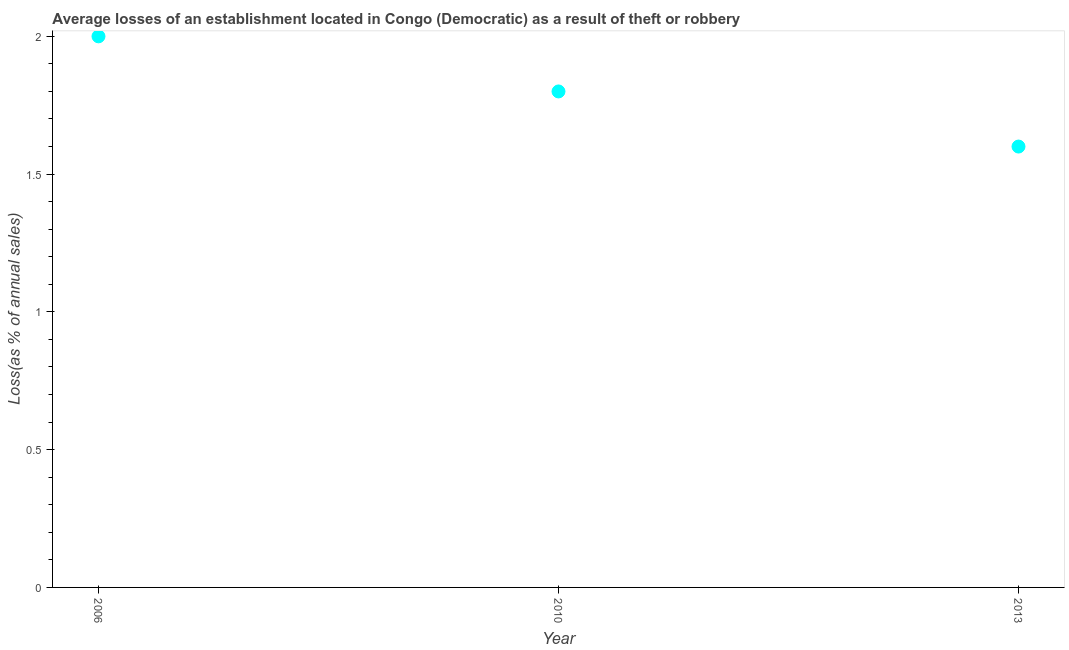What is the losses due to theft in 2013?
Offer a very short reply. 1.6. In which year was the losses due to theft maximum?
Keep it short and to the point. 2006. In which year was the losses due to theft minimum?
Offer a very short reply. 2013. What is the difference between the losses due to theft in 2006 and 2010?
Provide a short and direct response. 0.2. What is the average losses due to theft per year?
Your answer should be very brief. 1.8. What is the median losses due to theft?
Make the answer very short. 1.8. In how many years, is the losses due to theft greater than 0.2 %?
Your answer should be compact. 3. Do a majority of the years between 2006 and 2013 (inclusive) have losses due to theft greater than 1.3 %?
Your response must be concise. Yes. Is the losses due to theft in 2006 less than that in 2010?
Keep it short and to the point. No. What is the difference between the highest and the second highest losses due to theft?
Your response must be concise. 0.2. What is the difference between the highest and the lowest losses due to theft?
Offer a very short reply. 0.4. How many dotlines are there?
Your answer should be compact. 1. How many years are there in the graph?
Offer a terse response. 3. What is the difference between two consecutive major ticks on the Y-axis?
Provide a succinct answer. 0.5. Are the values on the major ticks of Y-axis written in scientific E-notation?
Ensure brevity in your answer.  No. Does the graph contain grids?
Provide a succinct answer. No. What is the title of the graph?
Provide a succinct answer. Average losses of an establishment located in Congo (Democratic) as a result of theft or robbery. What is the label or title of the Y-axis?
Ensure brevity in your answer.  Loss(as % of annual sales). What is the Loss(as % of annual sales) in 2006?
Offer a very short reply. 2. What is the Loss(as % of annual sales) in 2010?
Your response must be concise. 1.8. What is the difference between the Loss(as % of annual sales) in 2006 and 2013?
Give a very brief answer. 0.4. What is the difference between the Loss(as % of annual sales) in 2010 and 2013?
Your answer should be compact. 0.2. What is the ratio of the Loss(as % of annual sales) in 2006 to that in 2010?
Provide a succinct answer. 1.11. 